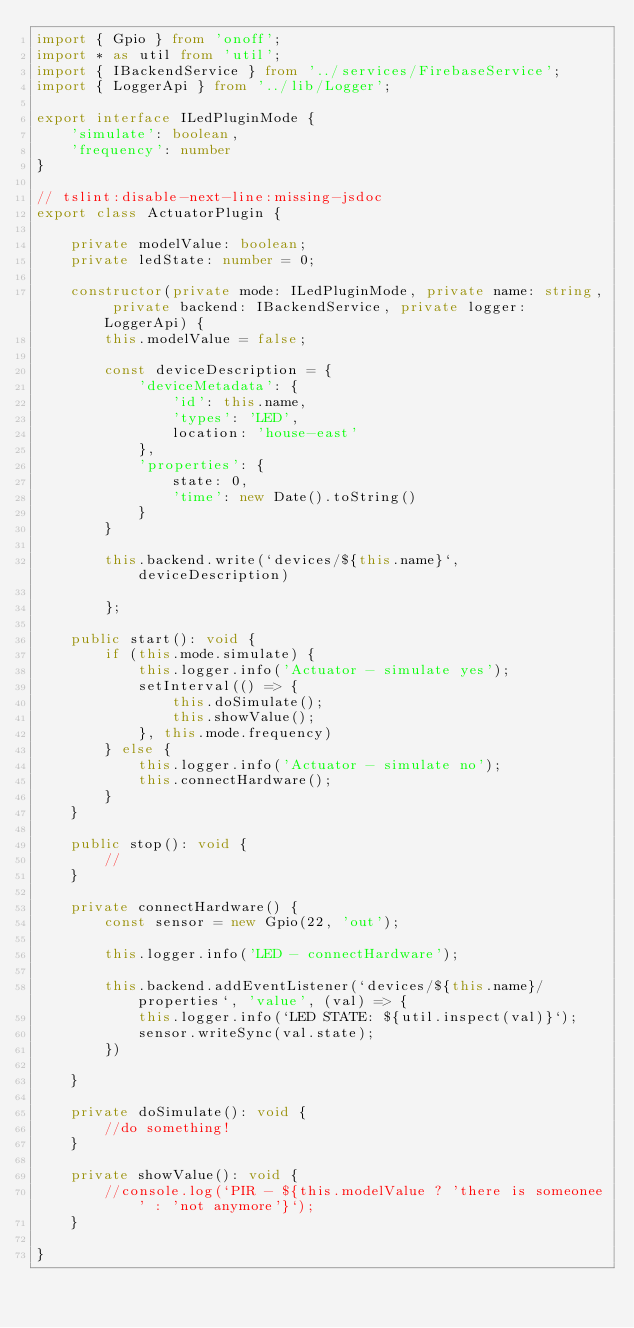Convert code to text. <code><loc_0><loc_0><loc_500><loc_500><_TypeScript_>import { Gpio } from 'onoff';
import * as util from 'util';
import { IBackendService } from '../services/FirebaseService';
import { LoggerApi } from '../lib/Logger';

export interface ILedPluginMode {
    'simulate': boolean,
    'frequency': number
}

// tslint:disable-next-line:missing-jsdoc
export class ActuatorPlugin {

    private modelValue: boolean;
    private ledState: number = 0;

    constructor(private mode: ILedPluginMode, private name: string, private backend: IBackendService, private logger: LoggerApi) {
        this.modelValue = false;

        const deviceDescription = {
            'deviceMetadata': {
                'id': this.name,
                'types': 'LED',
                location: 'house-east'
            },
            'properties': {
                state: 0,
                'time': new Date().toString()
            }
        } 

        this.backend.write(`devices/${this.name}`, deviceDescription)

        }; 

    public start(): void {
        if (this.mode.simulate) {
            this.logger.info('Actuator - simulate yes');
            setInterval(() => {
                this.doSimulate();
                this.showValue();
            }, this.mode.frequency)
        } else {
            this.logger.info('Actuator - simulate no');
            this.connectHardware();
        }
    }

    public stop(): void {
        //
    }

    private connectHardware() {
        const sensor = new Gpio(22, 'out');

        this.logger.info('LED - connectHardware');

        this.backend.addEventListener(`devices/${this.name}/properties`, 'value', (val) => {
            this.logger.info(`LED STATE: ${util.inspect(val)}`);
            sensor.writeSync(val.state);
        })

    }

    private doSimulate(): void {
        //do something!
    }

    private showValue(): void {
        //console.log(`PIR - ${this.modelValue ? 'there is someonee' : 'not anymore'}`);
    }

}</code> 